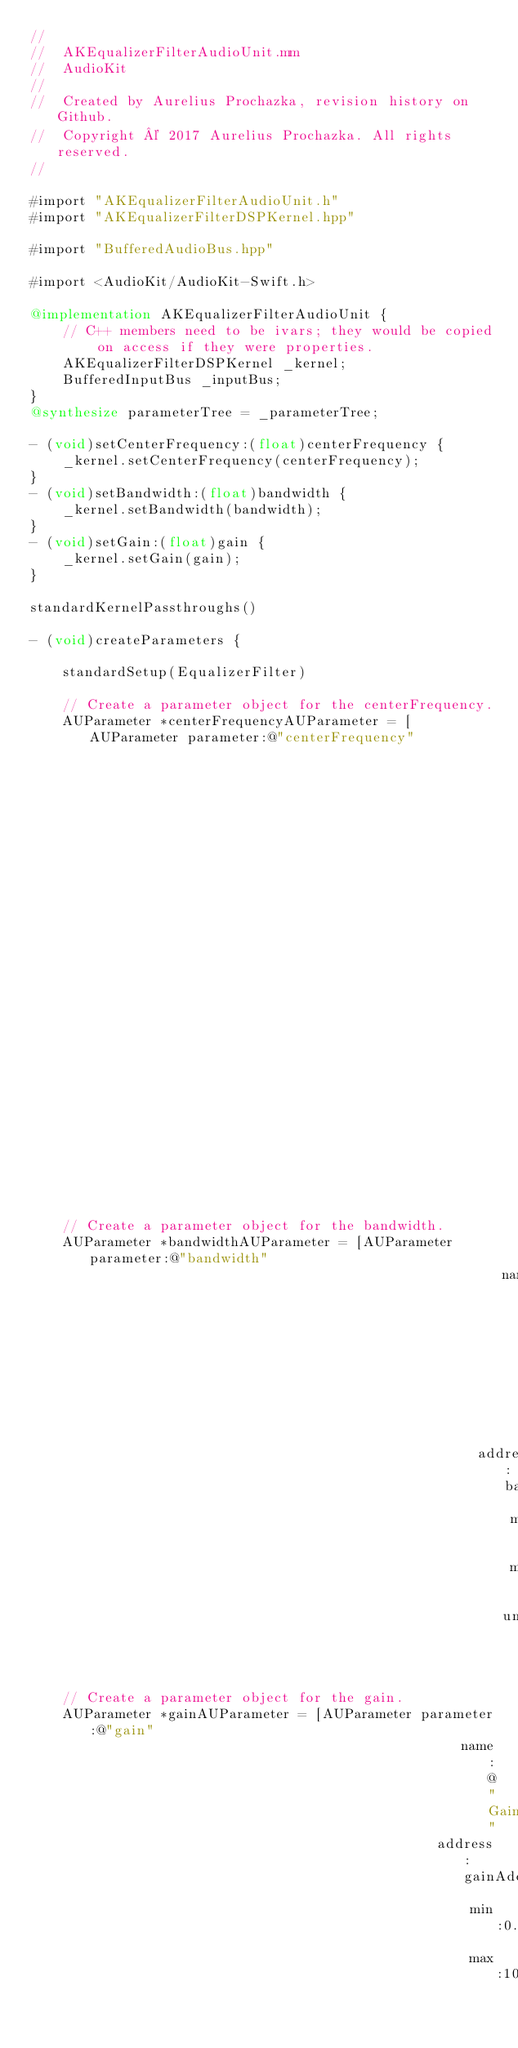Convert code to text. <code><loc_0><loc_0><loc_500><loc_500><_ObjectiveC_>//
//  AKEqualizerFilterAudioUnit.mm
//  AudioKit
//
//  Created by Aurelius Prochazka, revision history on Github.
//  Copyright © 2017 Aurelius Prochazka. All rights reserved.
//

#import "AKEqualizerFilterAudioUnit.h"
#import "AKEqualizerFilterDSPKernel.hpp"

#import "BufferedAudioBus.hpp"

#import <AudioKit/AudioKit-Swift.h>

@implementation AKEqualizerFilterAudioUnit {
    // C++ members need to be ivars; they would be copied on access if they were properties.
    AKEqualizerFilterDSPKernel _kernel;
    BufferedInputBus _inputBus;
}
@synthesize parameterTree = _parameterTree;

- (void)setCenterFrequency:(float)centerFrequency {
    _kernel.setCenterFrequency(centerFrequency);
}
- (void)setBandwidth:(float)bandwidth {
    _kernel.setBandwidth(bandwidth);
}
- (void)setGain:(float)gain {
    _kernel.setGain(gain);
}

standardKernelPassthroughs()

- (void)createParameters {

    standardSetup(EqualizerFilter)

    // Create a parameter object for the centerFrequency.
    AUParameter *centerFrequencyAUParameter = [AUParameter parameter:@"centerFrequency"
                                                                name:@"Center Frequency (Hz)"
                                                             address:centerFrequencyAddress
                                                                 min:12.0
                                                                 max:20000.0
                                                                unit:kAudioUnitParameterUnit_Hertz];

    // Create a parameter object for the bandwidth.
    AUParameter *bandwidthAUParameter = [AUParameter parameter:@"bandwidth"
                                                          name:@"Bandwidth (Hz)"
                                                       address:bandwidthAddress
                                                           min:0.0
                                                           max:20000.0
                                                          unit:kAudioUnitParameterUnit_Hertz];
    // Create a parameter object for the gain.
    AUParameter *gainAUParameter = [AUParameter parameter:@"gain"
                                                     name:@"Gain"
                                                  address:gainAddress
                                                      min:0.0
                                                      max:1000.0</code> 